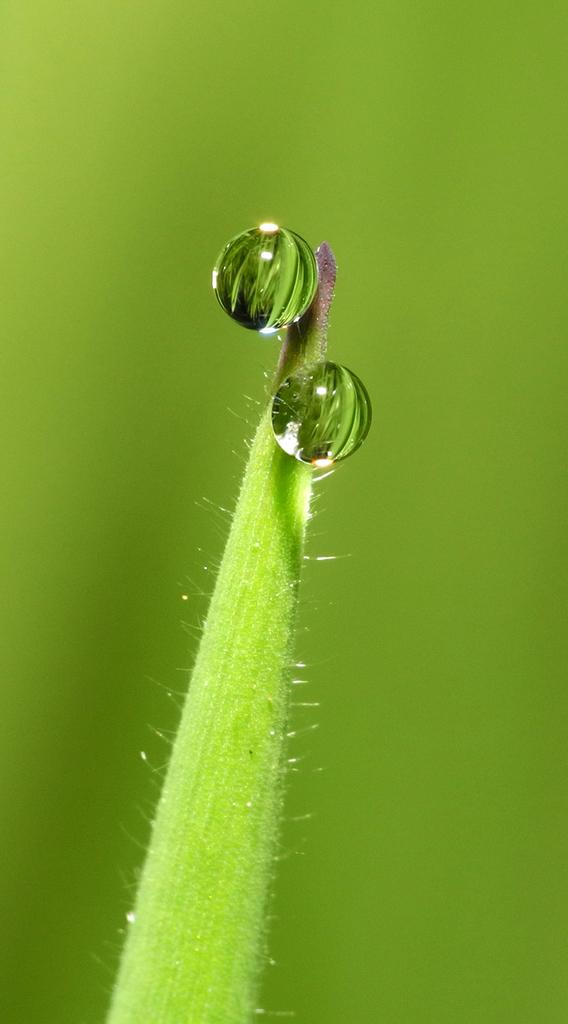What can be seen on the leaf in the foreground of the image? There are water droplets on a leaf in the foreground of the image. What color dominates the background of the image? The background of the image is green. What type of boat is visible in the image? There is no boat present in the image. What is the purpose of the bomb in the image? There is no bomb present in the image. 